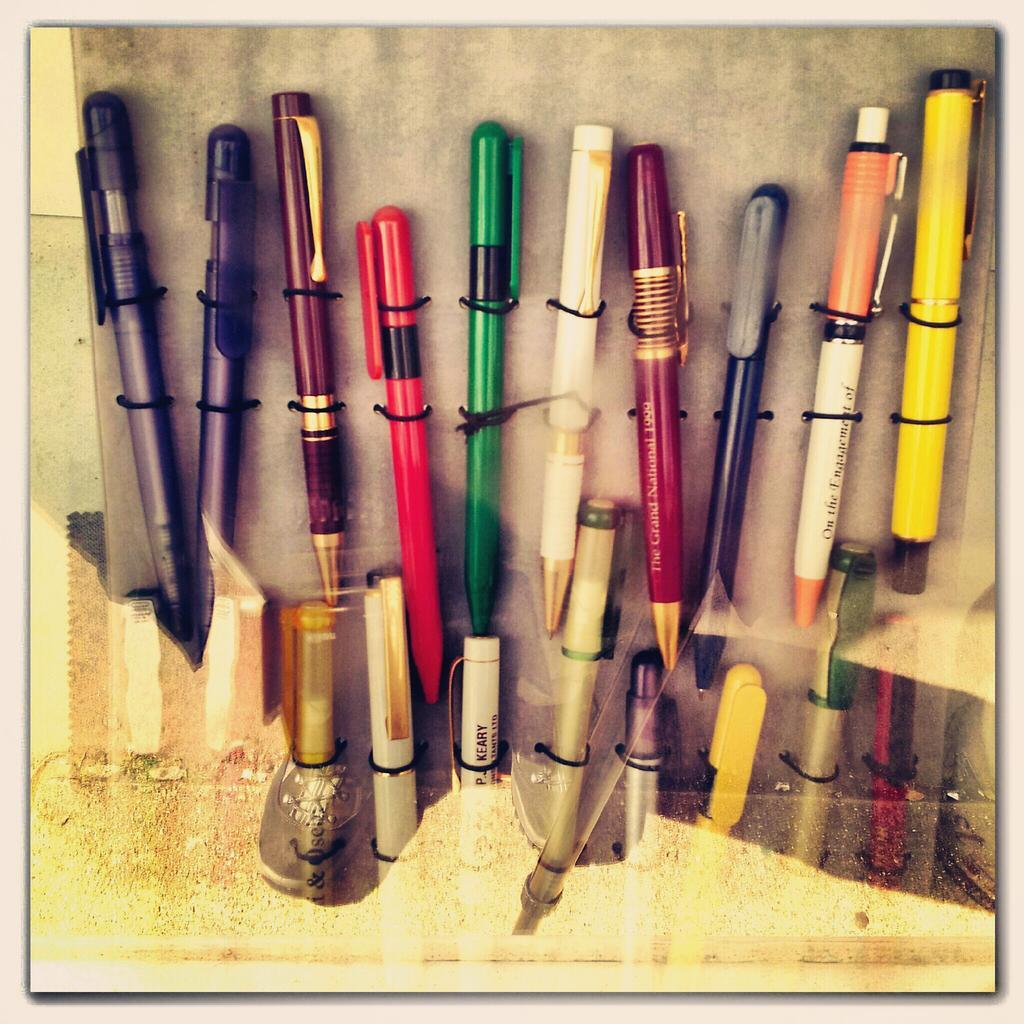Please provide a concise description of this image. In this image, we can see glass. Through the glass we can see few pens are tied with black objects. 